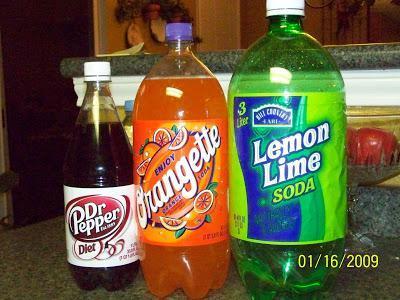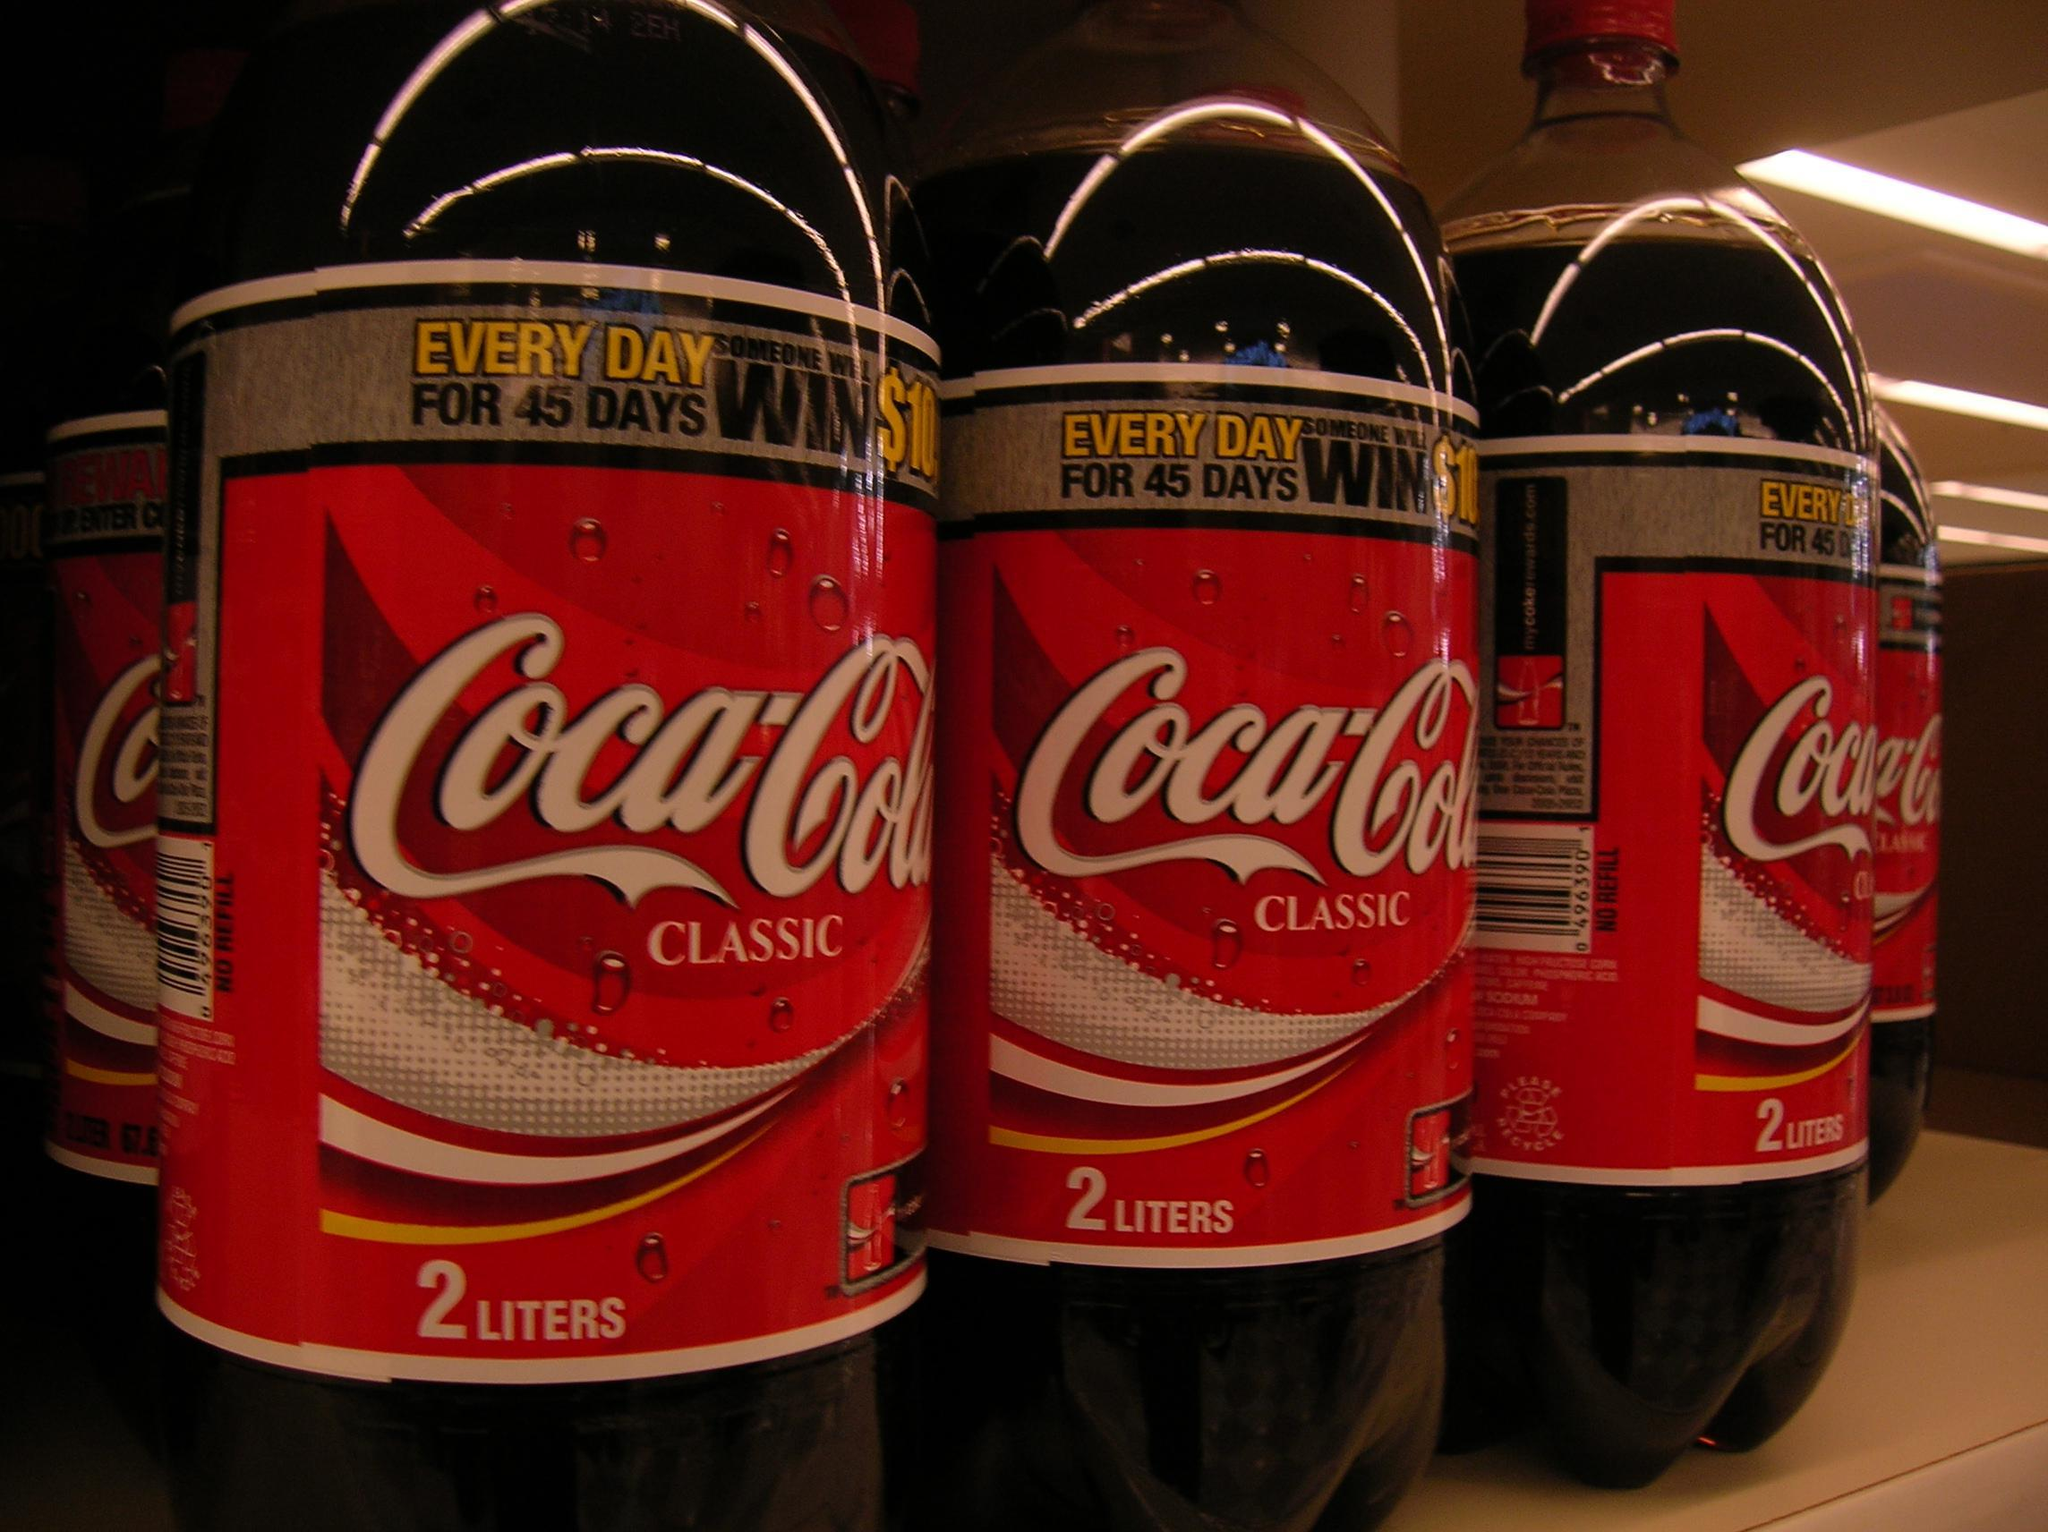The first image is the image on the left, the second image is the image on the right. Evaluate the accuracy of this statement regarding the images: "There are exactly three bottles of soda.". Is it true? Answer yes or no. No. The first image is the image on the left, the second image is the image on the right. Examine the images to the left and right. Is the description "The left image features one full bottle of cola with a red wrapper standing upright, and the right image contains two full bottles of cola with red wrappers positioned side-by-side." accurate? Answer yes or no. No. 